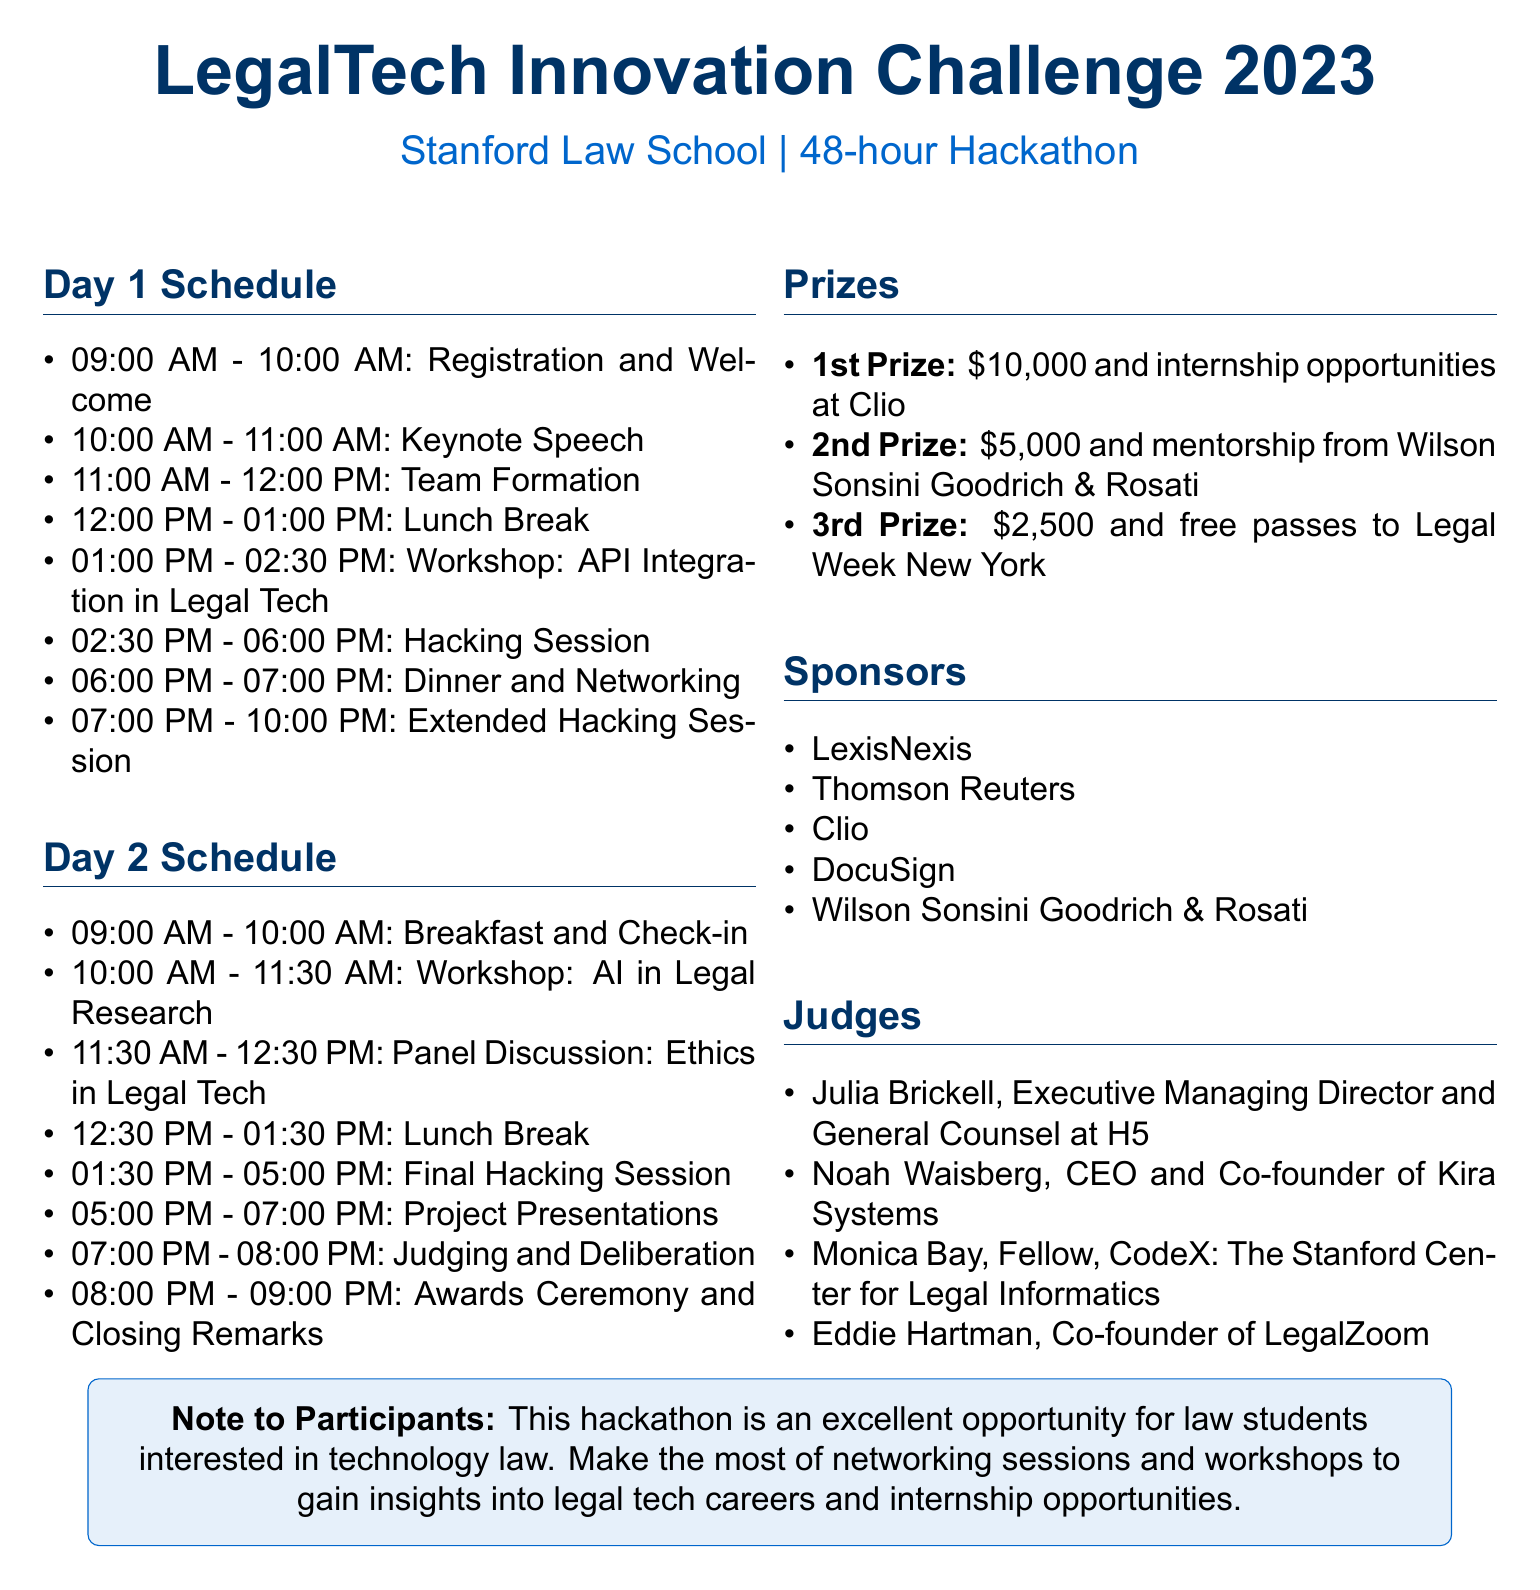What is the first activity on Day 1? The first activity listed under Day 1 is "Registration and Welcome."
Answer: Registration and Welcome Who is the keynote speaker? The document states that the keynote speaker is Mark Chandler.
Answer: Mark Chandler What time does the final hacking session start on Day 2? According to Day 2's schedule, the final hacking session starts at 01:30 PM.
Answer: 01:30 PM How long is the hackathon duration? The duration of the hackathon is specified as 48 hours.
Answer: 48 hours What is awarded for the 1st Prize? The document lists the reward for the 1st Prize as $10,000 and internship opportunities at Clio.
Answer: $10,000 and internship opportunities at Clio How many judges are there in total? The document specifies four judges involved in the event.
Answer: 4 What type of event is scheduled at 11:30 AM on Day 2? The event scheduled at that time is a "Panel Discussion: Ethics in Legal Tech."
Answer: Panel Discussion: Ethics in Legal Tech Who is the mentor for the workshop on Day 1? The document indicates that the workshop is led by Daniel Lewis.
Answer: Daniel Lewis 